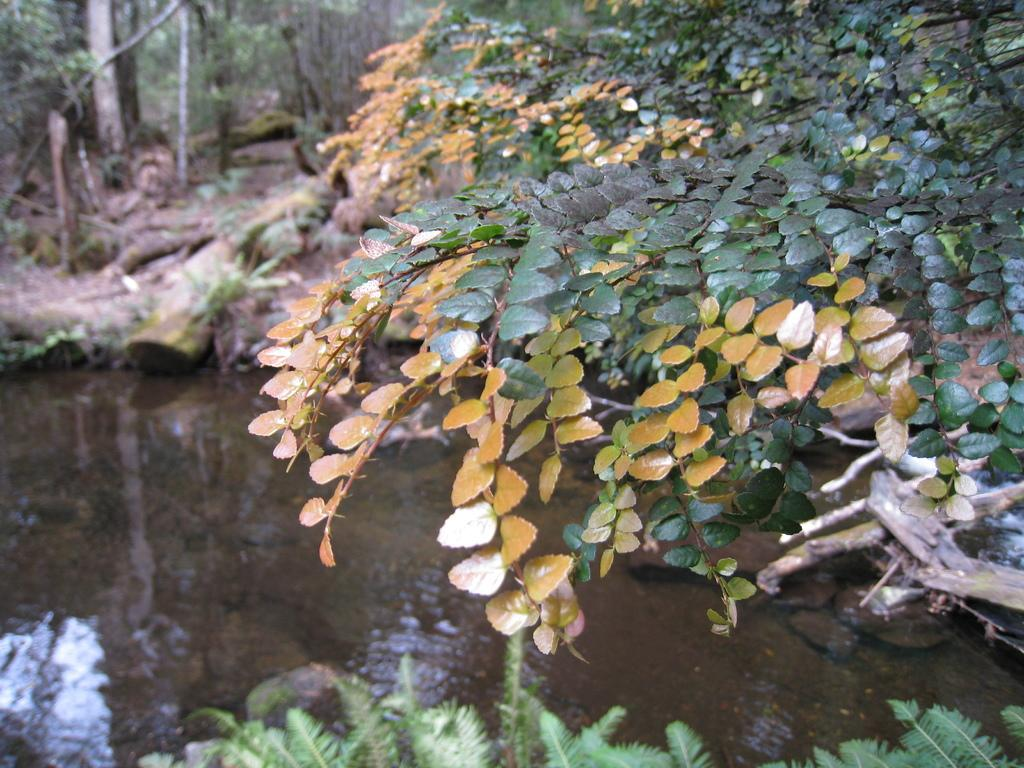What is at the bottom of the image? There is water at the bottom of the image. What can be seen in the distance in the image? There are trees and wood visible in the background of the image. What is present in the front of the image? There are leaves in the front of the image. What is the tendency of the mother in the image? There is no mother present in the image, so it is not possible to determine any tendencies. 